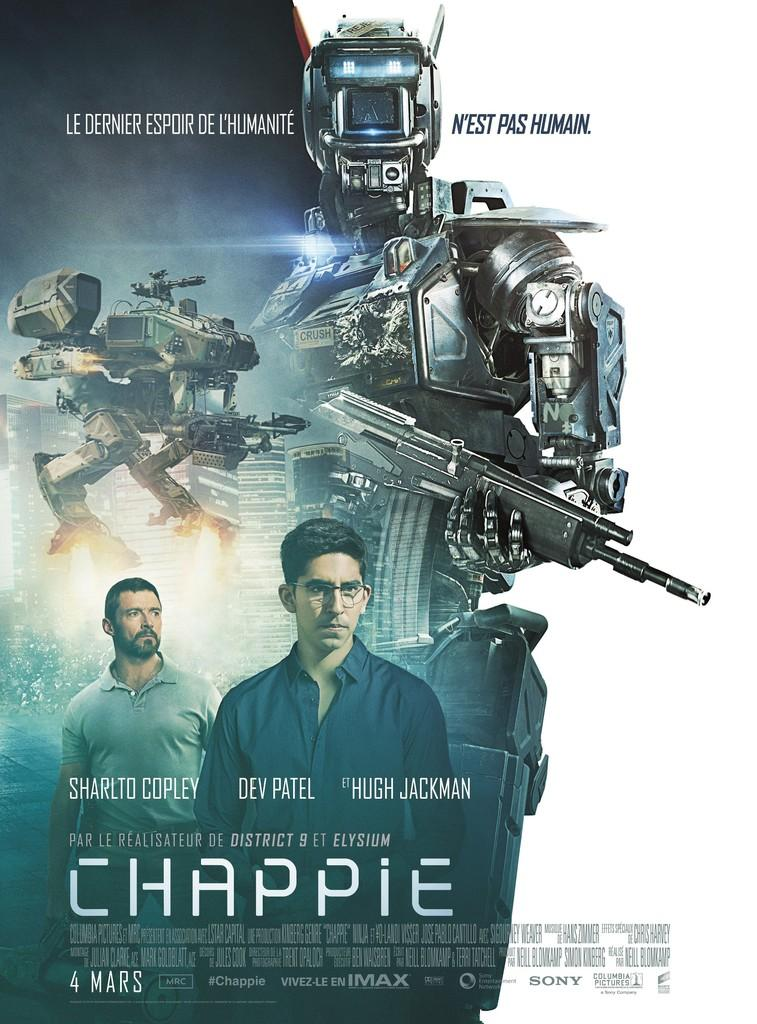<image>
Provide a brief description of the given image. A poster for the movie Chappie shows robots and men in armor. 